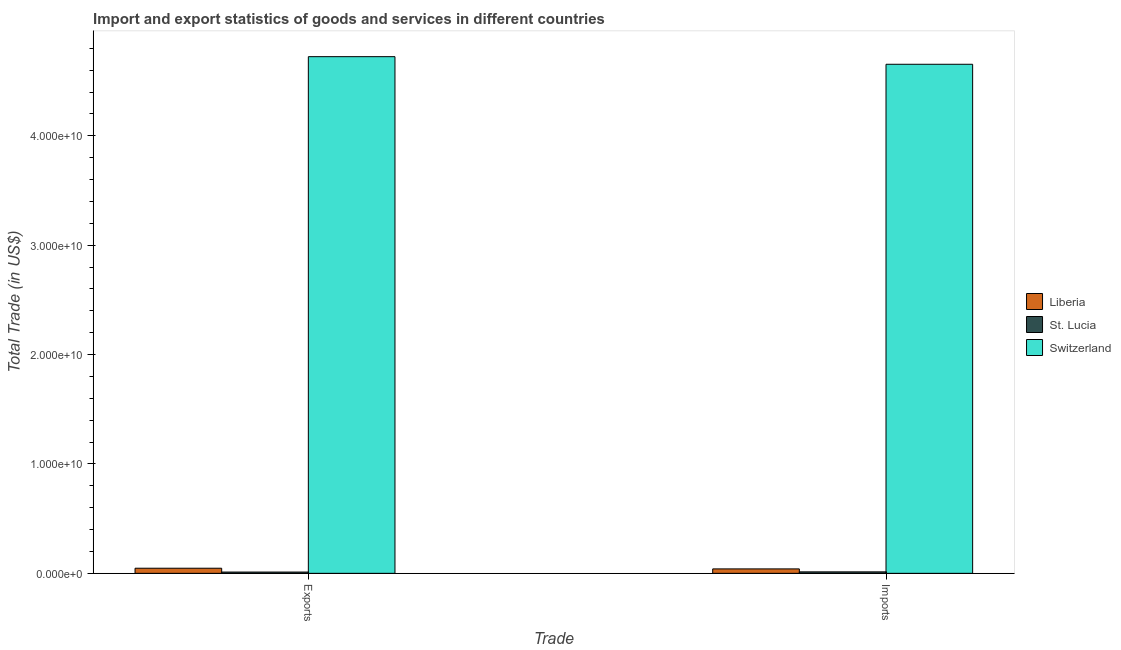How many groups of bars are there?
Offer a terse response. 2. How many bars are there on the 1st tick from the left?
Offer a terse response. 3. How many bars are there on the 1st tick from the right?
Ensure brevity in your answer.  3. What is the label of the 1st group of bars from the left?
Give a very brief answer. Exports. What is the export of goods and services in St. Lucia?
Offer a very short reply. 1.16e+08. Across all countries, what is the maximum imports of goods and services?
Your response must be concise. 4.65e+1. Across all countries, what is the minimum imports of goods and services?
Your answer should be very brief. 1.34e+08. In which country was the imports of goods and services maximum?
Provide a succinct answer. Switzerland. In which country was the imports of goods and services minimum?
Keep it short and to the point. St. Lucia. What is the total export of goods and services in the graph?
Your answer should be very brief. 4.78e+1. What is the difference between the export of goods and services in Switzerland and that in Liberia?
Offer a very short reply. 4.68e+1. What is the difference between the export of goods and services in Switzerland and the imports of goods and services in St. Lucia?
Your answer should be very brief. 4.71e+1. What is the average export of goods and services per country?
Provide a short and direct response. 1.59e+1. What is the difference between the imports of goods and services and export of goods and services in St. Lucia?
Provide a short and direct response. 1.81e+07. In how many countries, is the imports of goods and services greater than 42000000000 US$?
Provide a short and direct response. 1. What is the ratio of the imports of goods and services in Liberia to that in Switzerland?
Your response must be concise. 0.01. Is the export of goods and services in St. Lucia less than that in Liberia?
Make the answer very short. Yes. In how many countries, is the export of goods and services greater than the average export of goods and services taken over all countries?
Ensure brevity in your answer.  1. What does the 1st bar from the left in Exports represents?
Your answer should be very brief. Liberia. What does the 2nd bar from the right in Exports represents?
Offer a very short reply. St. Lucia. How many bars are there?
Ensure brevity in your answer.  6. Are all the bars in the graph horizontal?
Provide a succinct answer. No. How many countries are there in the graph?
Your answer should be compact. 3. Does the graph contain grids?
Offer a terse response. No. What is the title of the graph?
Keep it short and to the point. Import and export statistics of goods and services in different countries. What is the label or title of the X-axis?
Ensure brevity in your answer.  Trade. What is the label or title of the Y-axis?
Offer a very short reply. Total Trade (in US$). What is the Total Trade (in US$) in Liberia in Exports?
Make the answer very short. 4.67e+08. What is the Total Trade (in US$) in St. Lucia in Exports?
Your answer should be very brief. 1.16e+08. What is the Total Trade (in US$) in Switzerland in Exports?
Your answer should be very brief. 4.72e+1. What is the Total Trade (in US$) in Liberia in Imports?
Provide a succinct answer. 4.05e+08. What is the Total Trade (in US$) of St. Lucia in Imports?
Your answer should be compact. 1.34e+08. What is the Total Trade (in US$) in Switzerland in Imports?
Offer a very short reply. 4.65e+1. Across all Trade, what is the maximum Total Trade (in US$) of Liberia?
Provide a short and direct response. 4.67e+08. Across all Trade, what is the maximum Total Trade (in US$) in St. Lucia?
Your answer should be very brief. 1.34e+08. Across all Trade, what is the maximum Total Trade (in US$) of Switzerland?
Provide a succinct answer. 4.72e+1. Across all Trade, what is the minimum Total Trade (in US$) of Liberia?
Offer a terse response. 4.05e+08. Across all Trade, what is the minimum Total Trade (in US$) in St. Lucia?
Provide a short and direct response. 1.16e+08. Across all Trade, what is the minimum Total Trade (in US$) in Switzerland?
Your response must be concise. 4.65e+1. What is the total Total Trade (in US$) in Liberia in the graph?
Offer a terse response. 8.72e+08. What is the total Total Trade (in US$) in St. Lucia in the graph?
Provide a short and direct response. 2.50e+08. What is the total Total Trade (in US$) of Switzerland in the graph?
Offer a terse response. 9.38e+1. What is the difference between the Total Trade (in US$) in Liberia in Exports and that in Imports?
Offer a very short reply. 6.20e+07. What is the difference between the Total Trade (in US$) of St. Lucia in Exports and that in Imports?
Your response must be concise. -1.81e+07. What is the difference between the Total Trade (in US$) in Switzerland in Exports and that in Imports?
Offer a terse response. 6.96e+08. What is the difference between the Total Trade (in US$) in Liberia in Exports and the Total Trade (in US$) in St. Lucia in Imports?
Keep it short and to the point. 3.33e+08. What is the difference between the Total Trade (in US$) of Liberia in Exports and the Total Trade (in US$) of Switzerland in Imports?
Provide a short and direct response. -4.61e+1. What is the difference between the Total Trade (in US$) of St. Lucia in Exports and the Total Trade (in US$) of Switzerland in Imports?
Give a very brief answer. -4.64e+1. What is the average Total Trade (in US$) of Liberia per Trade?
Give a very brief answer. 4.36e+08. What is the average Total Trade (in US$) in St. Lucia per Trade?
Your answer should be compact. 1.25e+08. What is the average Total Trade (in US$) in Switzerland per Trade?
Provide a short and direct response. 4.69e+1. What is the difference between the Total Trade (in US$) in Liberia and Total Trade (in US$) in St. Lucia in Exports?
Your answer should be very brief. 3.51e+08. What is the difference between the Total Trade (in US$) in Liberia and Total Trade (in US$) in Switzerland in Exports?
Offer a very short reply. -4.68e+1. What is the difference between the Total Trade (in US$) of St. Lucia and Total Trade (in US$) of Switzerland in Exports?
Your answer should be compact. -4.71e+1. What is the difference between the Total Trade (in US$) in Liberia and Total Trade (in US$) in St. Lucia in Imports?
Make the answer very short. 2.71e+08. What is the difference between the Total Trade (in US$) in Liberia and Total Trade (in US$) in Switzerland in Imports?
Your response must be concise. -4.61e+1. What is the difference between the Total Trade (in US$) of St. Lucia and Total Trade (in US$) of Switzerland in Imports?
Provide a short and direct response. -4.64e+1. What is the ratio of the Total Trade (in US$) of Liberia in Exports to that in Imports?
Keep it short and to the point. 1.15. What is the ratio of the Total Trade (in US$) in St. Lucia in Exports to that in Imports?
Offer a terse response. 0.87. What is the difference between the highest and the second highest Total Trade (in US$) in Liberia?
Provide a short and direct response. 6.20e+07. What is the difference between the highest and the second highest Total Trade (in US$) in St. Lucia?
Offer a terse response. 1.81e+07. What is the difference between the highest and the second highest Total Trade (in US$) of Switzerland?
Provide a short and direct response. 6.96e+08. What is the difference between the highest and the lowest Total Trade (in US$) of Liberia?
Offer a terse response. 6.20e+07. What is the difference between the highest and the lowest Total Trade (in US$) in St. Lucia?
Offer a terse response. 1.81e+07. What is the difference between the highest and the lowest Total Trade (in US$) of Switzerland?
Keep it short and to the point. 6.96e+08. 